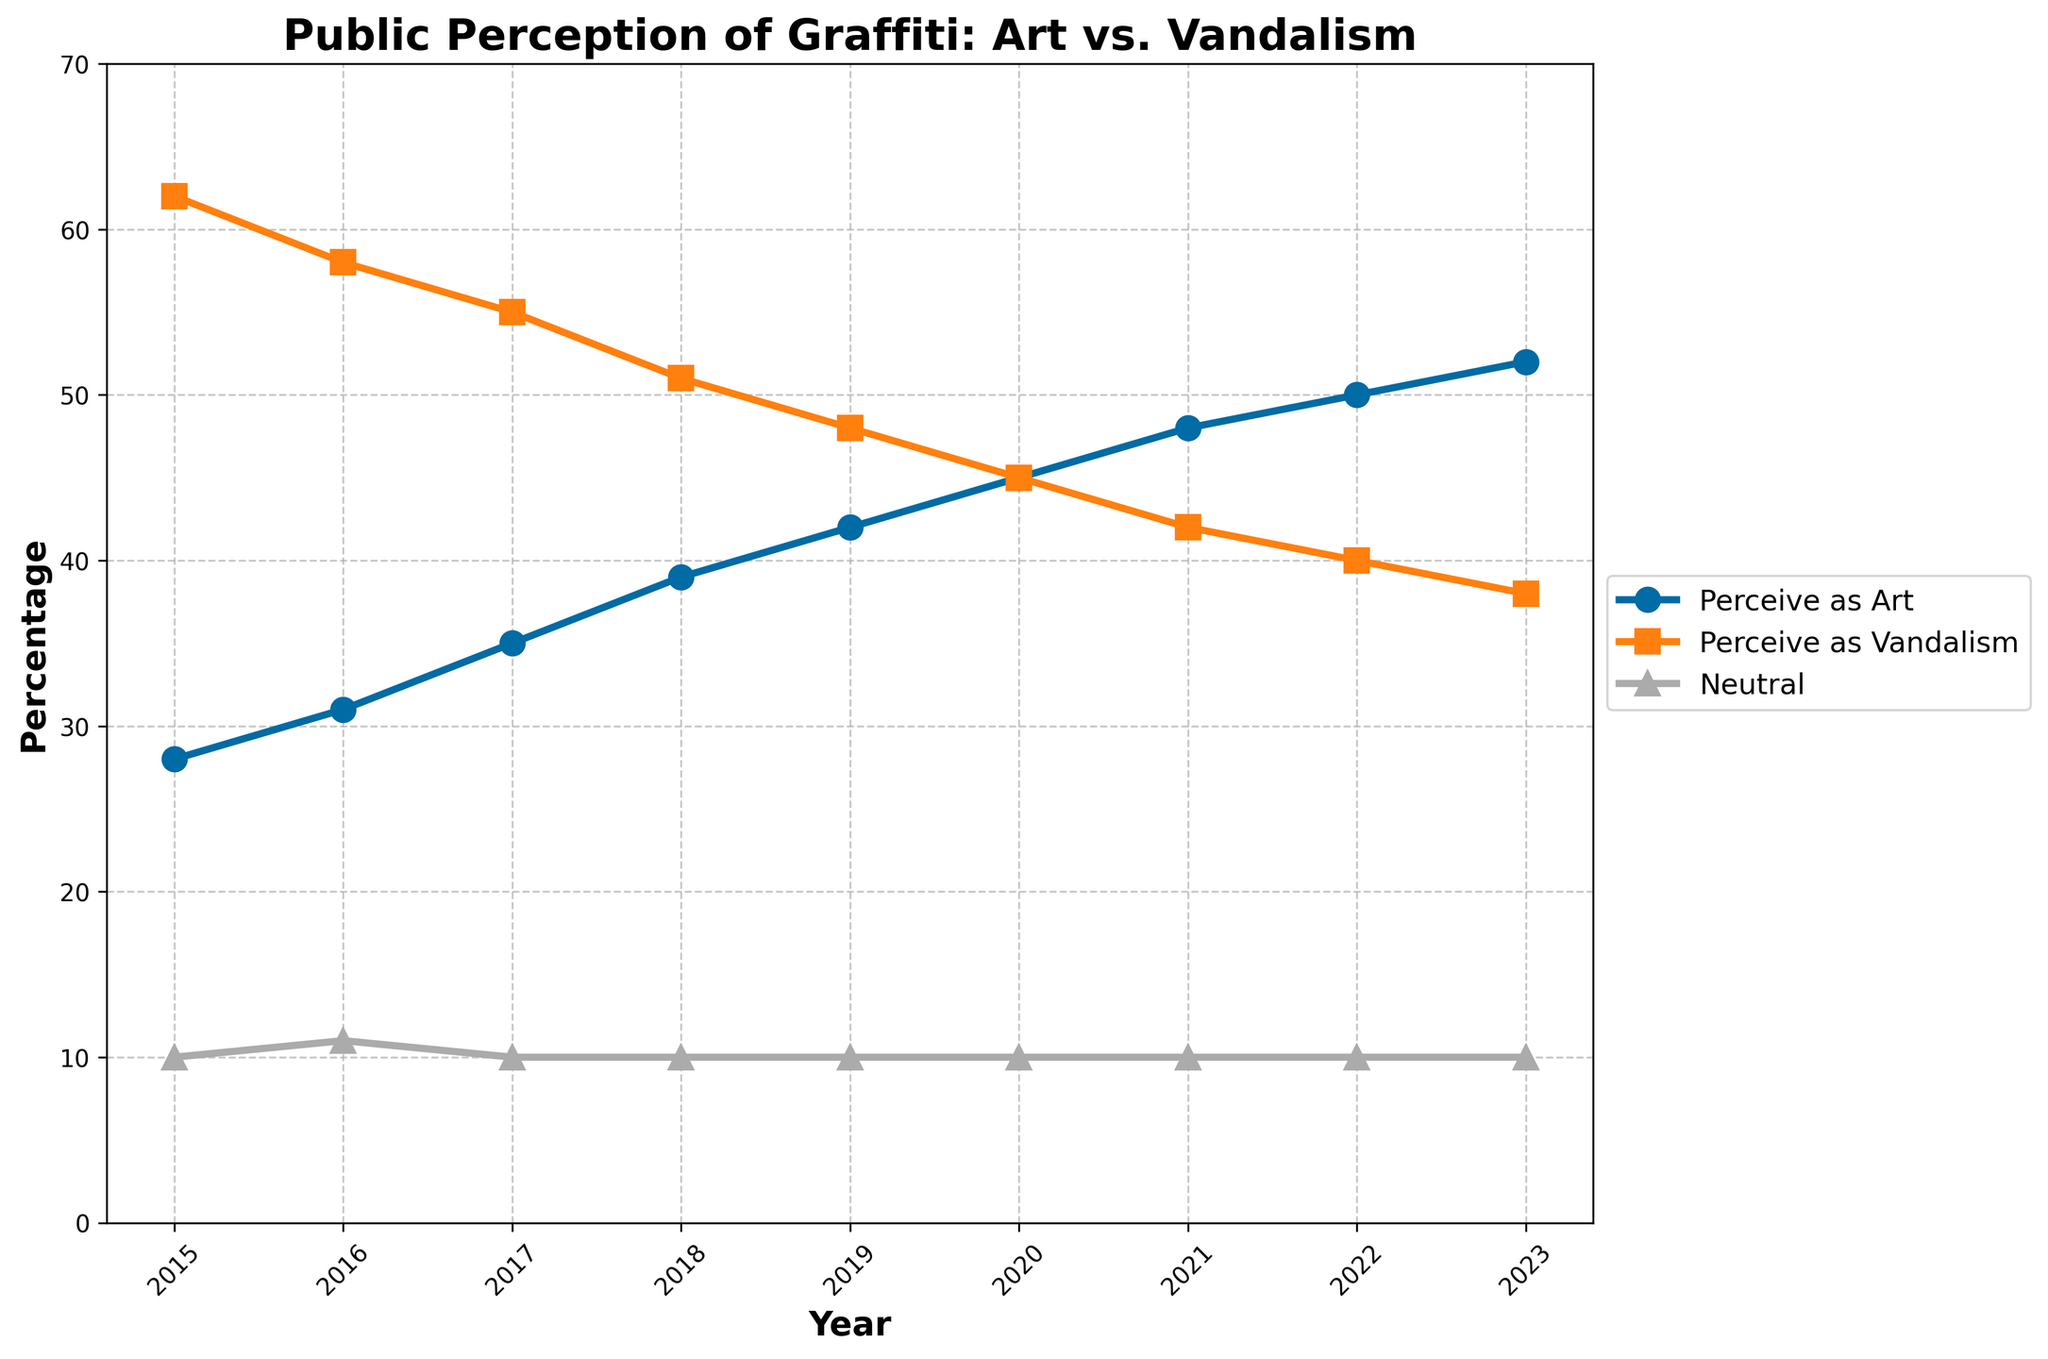What is the percentage change in the public perception of graffiti as art from 2015 to 2023? The percentage of those who perceive graffiti as art in 2015 was 28%, and in 2023 it is 52%. The percentage change is calculated as ((52 - 28) / 28) * 100%. This equals (24 / 28) * 100%, which is approximately 85.71%.
Answer: 85.71% In which year did the perception of graffiti as vandalism fall below 50% for the first time? The perception of graffiti as vandalism fell below 50% for the first time in 2019, as in 2018 it was 51% and in 2019 it decreased to 48%.
Answer: 2019 By how much did the percentage of people perceiving graffiti as art differ from those perceiving it as vandalism in 2022? In 2022, 50% perceived graffiti as art, and 40% perceived it as vandalism. The difference is 50% - 40% = 10%.
Answer: 10% What was the average percentage of people who were neutral about graffiti over the studied years? The neutral percentage is 10% each year from 2015 to 2023. Since it remains constant at 10%, the average over these years is simply 10%.
Answer: 10% Which year shows the highest increase in the perception of graffiti as art compared to the previous year? The perception as art goes from 28% in 2015 to 31% in 2016 (an increase of 3%), 31% to 35% in 2017 (4%), 35% to 39% in 2018 (4%), 39% to 42% in 2019 (3%), 42% to 45% in 2020 (3%), 45% to 48% in 2021 (3%), 48% to 50% in 2022 (2%), and 50% to 52% in 2023 (2%). The highest increase, therefore, occurred in 2017 and 2018, both with an increase of 4%.
Answer: 2017 and 2018 How did the public perception of graffiti as vandalism trend from 2015 to 2023? From 2015 to 2023, the perception of graffiti as vandalism shows a steady decline: 62% in 2015, 58% in 2016, 55% in 2017, 51% in 2018, 48% in 2019, 45% in 2020, 42% in 2021, 40% in 2022, and 38% in 2023. This indicates a consistent downward trend.
Answer: Steady decline In what year did the percentages of people perceiving graffiti as art and vandalism become equal? The percentages of people perceiving graffiti as art and vandalism became equal in 2020, where both were 45%.
Answer: 2020 